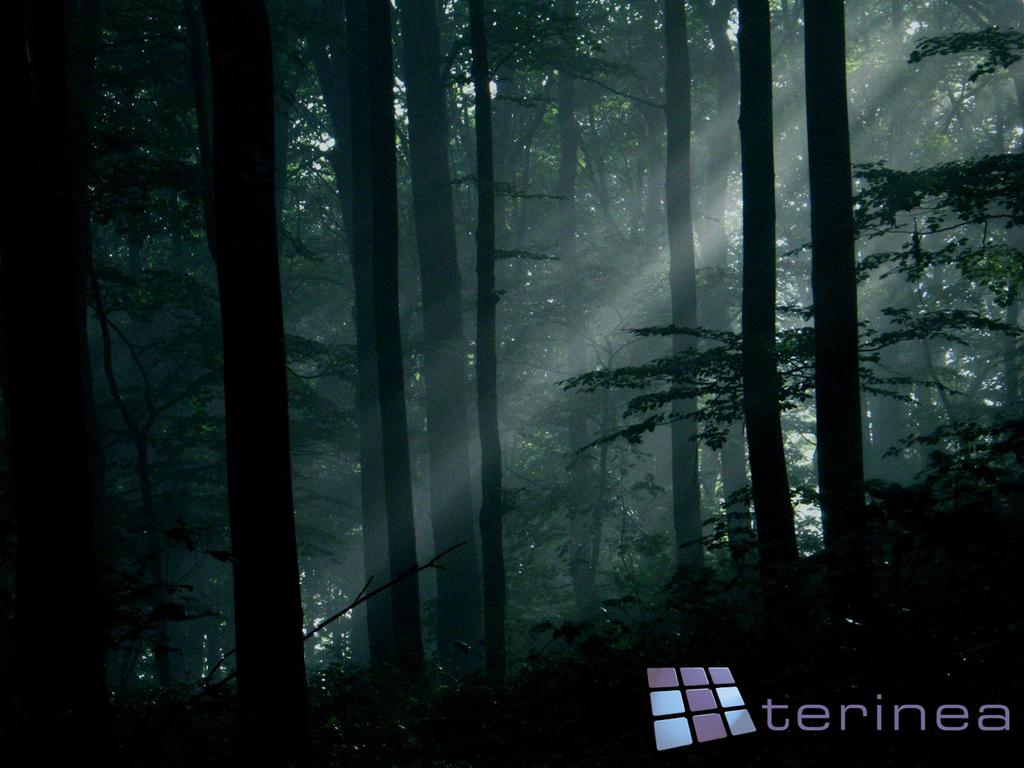What type of vegetation can be seen in the image? There are trees in the image. Can you describe the trees in the image? The provided facts do not give specific details about the trees, so we cannot describe them further. What might be the purpose of the trees in the image? The trees in the image could provide shade, serve as a habitat for wildlife, or contribute to the overall aesthetic of the scene. What type of food is being served by the river in the image? There is no river or food present in the image; it only features trees. 